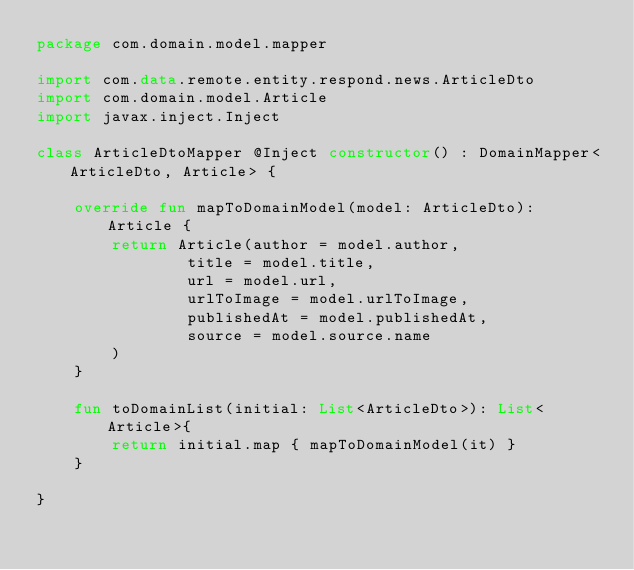Convert code to text. <code><loc_0><loc_0><loc_500><loc_500><_Kotlin_>package com.domain.model.mapper

import com.data.remote.entity.respond.news.ArticleDto
import com.domain.model.Article
import javax.inject.Inject

class ArticleDtoMapper @Inject constructor() : DomainMapper<ArticleDto, Article> {

    override fun mapToDomainModel(model: ArticleDto): Article {
        return Article(author = model.author,
                title = model.title,
                url = model.url,
                urlToImage = model.urlToImage,
                publishedAt = model.publishedAt,
                source = model.source.name
        )
    }

    fun toDomainList(initial: List<ArticleDto>): List<Article>{
        return initial.map { mapToDomainModel(it) }
    }

}</code> 